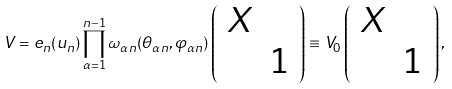Convert formula to latex. <formula><loc_0><loc_0><loc_500><loc_500>V = e _ { n } ( u _ { n } ) \prod _ { \alpha = 1 } ^ { n - 1 } \omega _ { \alpha n } ( \theta _ { \alpha n } , \varphi _ { \alpha n } ) \left ( \begin{array} { c c } X & \\ & 1 \end{array} \right ) \equiv V _ { 0 } \left ( \begin{array} { c c } X & \\ & 1 \end{array} \right ) ,</formula> 